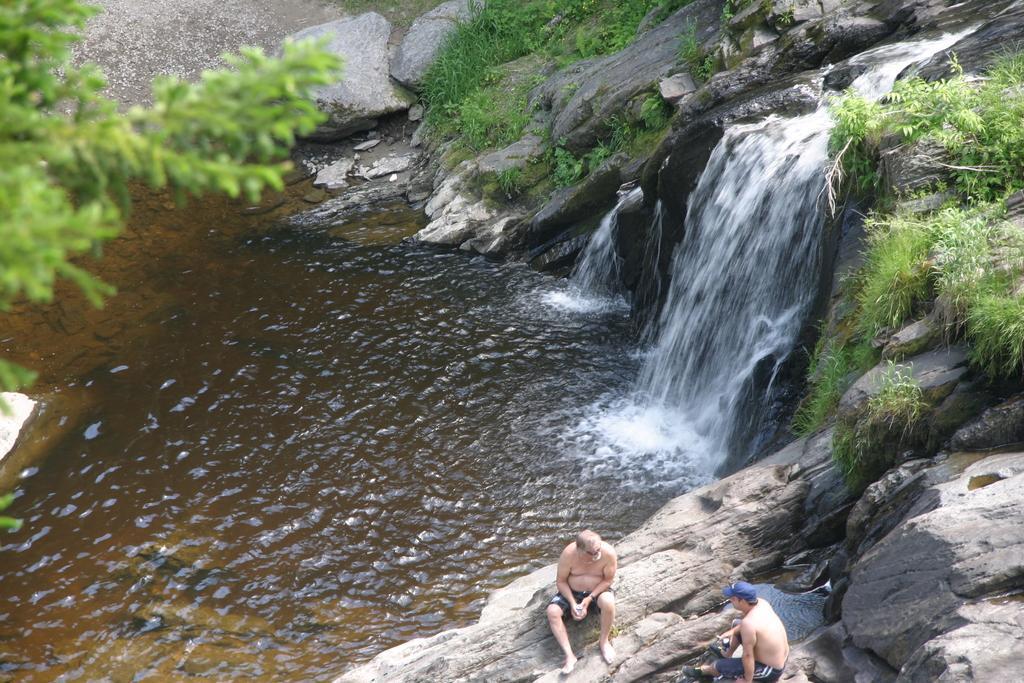Can you describe this image briefly? In this image I can see two persons sitting. In the background I can see the water and I can also see few plants and trees in green color. 